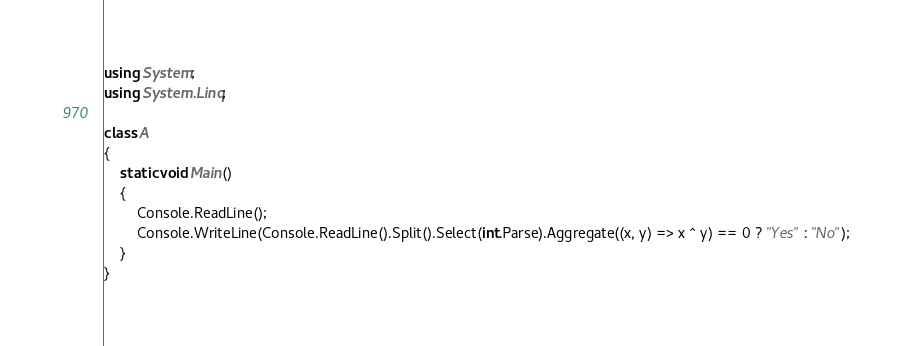<code> <loc_0><loc_0><loc_500><loc_500><_C#_>using System;
using System.Linq;

class A
{
	static void Main()
	{
		Console.ReadLine();
		Console.WriteLine(Console.ReadLine().Split().Select(int.Parse).Aggregate((x, y) => x ^ y) == 0 ? "Yes" : "No");
	}
}
</code> 